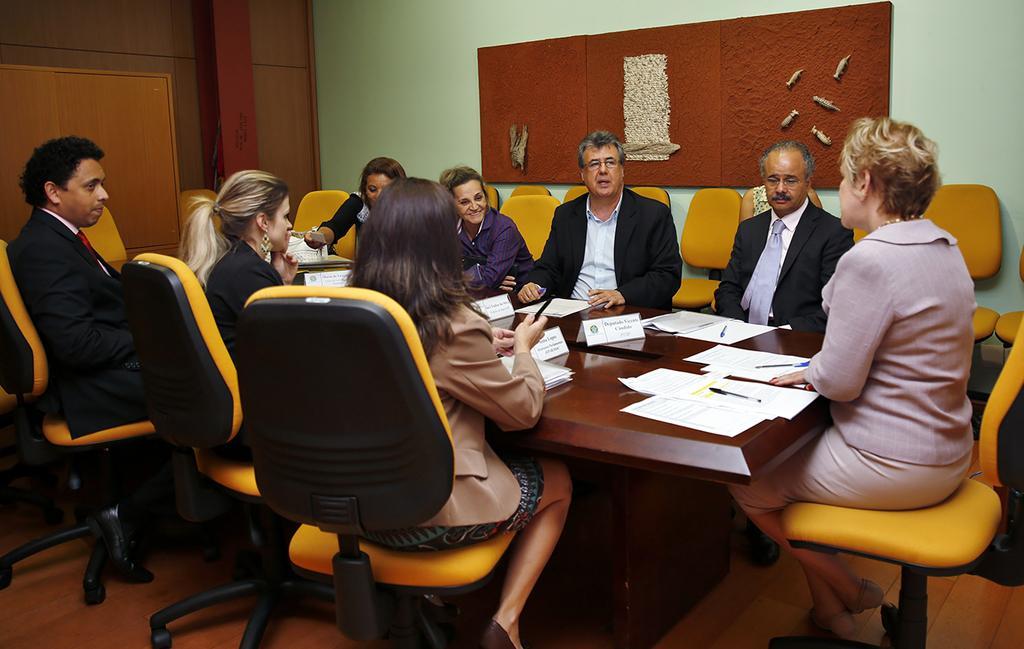Can you describe this image briefly? As we can see in the image there is a wall and few people sitting on chairs and in front of them there is a table. On table there is a poster, papers and pens. 